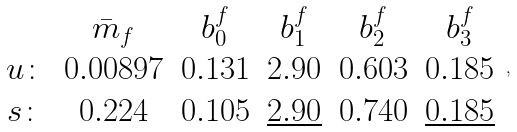Convert formula to latex. <formula><loc_0><loc_0><loc_500><loc_500>\begin{array} { c c c c c c } & \bar { m } _ { f } & b _ { 0 } ^ { f } & b _ { 1 } ^ { f } & b _ { 2 } ^ { f } & b _ { 3 } ^ { f } \\ u \colon & 0 . 0 0 8 9 7 & 0 . 1 3 1 & 2 . 9 0 & 0 . 6 0 3 & 0 . 1 8 5 \\ s \colon & 0 . 2 2 4 & 0 . 1 0 5 & \underline { 2 . 9 0 } & 0 . 7 4 0 & \underline { 0 . 1 8 5 } \end{array} \, ,</formula> 